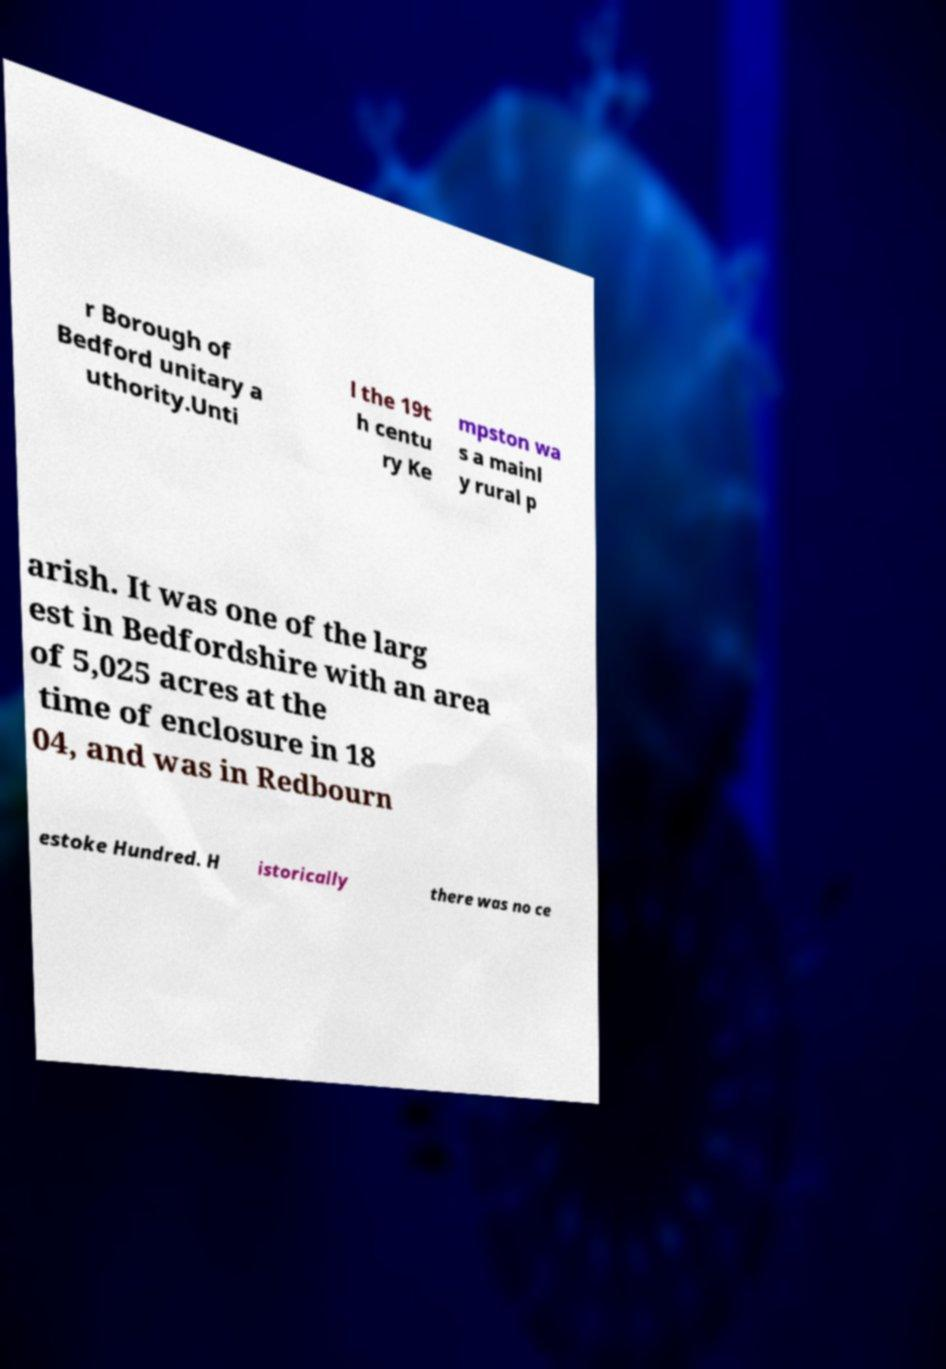I need the written content from this picture converted into text. Can you do that? r Borough of Bedford unitary a uthority.Unti l the 19t h centu ry Ke mpston wa s a mainl y rural p arish. It was one of the larg est in Bedfordshire with an area of 5,025 acres at the time of enclosure in 18 04, and was in Redbourn estoke Hundred. H istorically there was no ce 